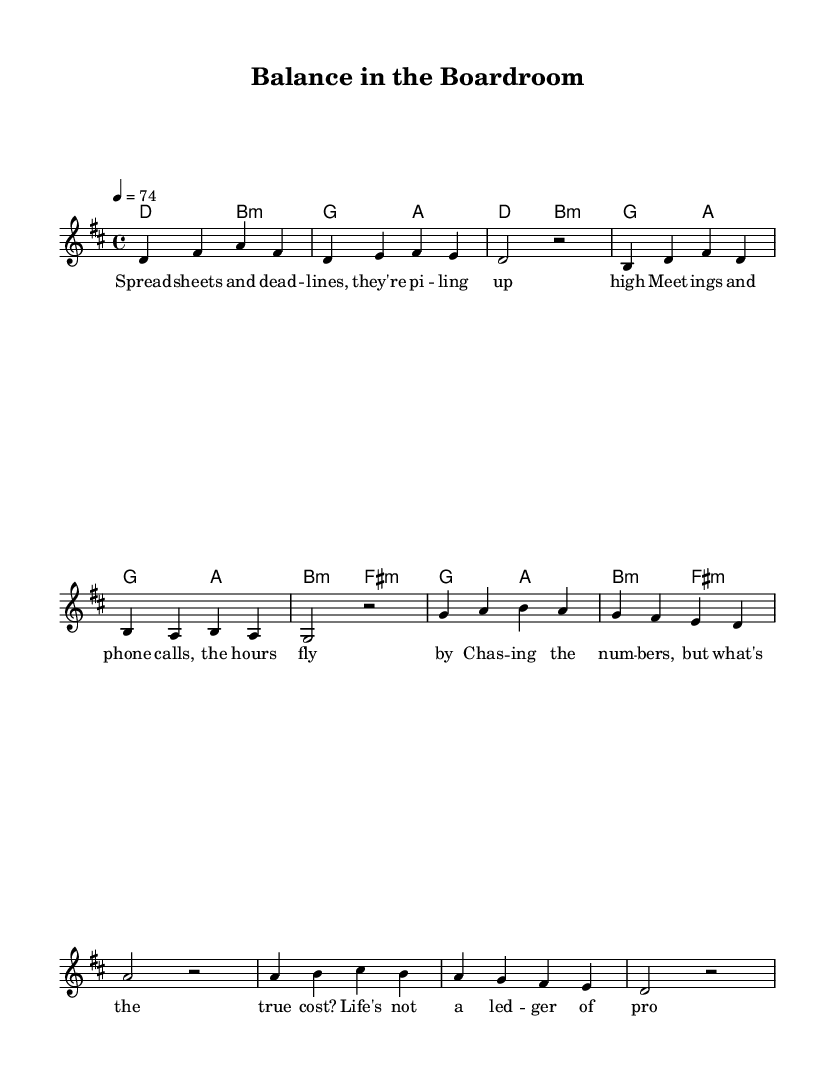What is the key signature of this music? The key signature is D major, which has two sharps (F# and C#). This is shown at the beginning of the music after the clef.
Answer: D major What is the time signature of this music? The time signature is 4/4, which indicates four beats per measure and a quarter note gets one beat. This is indicated at the start of the score just after the key signature.
Answer: 4/4 What is the tempo marking for this piece? The tempo marking is provided as "4 = 74", which means there are 74 beats per minute. This is indicated at the beginning of the musical score in the global settings.
Answer: 74 How many measures are in the verse? The verse consists of 4 measures, which can be counted by looking at the notations between the double bars in the melody section.
Answer: 4 What is the structure of the song? The song has a verse and a chorus structure, with the verse leading into the chorus, which is evident from the distinct sections marked by melody and lyrics.
Answer: Verse and Chorus In what musical genre does this piece belong? This piece is categorized as Pop, specifically introspective indie pop, which can be inferred from its lyrical content and melodic structure aimed at addressing themes like work-life balance.
Answer: Pop What is the primary theme of the lyrics? The primary theme of the lyrics revolves around the contrast between work and personal life, emphasizing the struggle with high-pressure careers. This thematic element is evident in the lyrics about meetings and the true cost of chasing numbers.
Answer: Work-life balance 